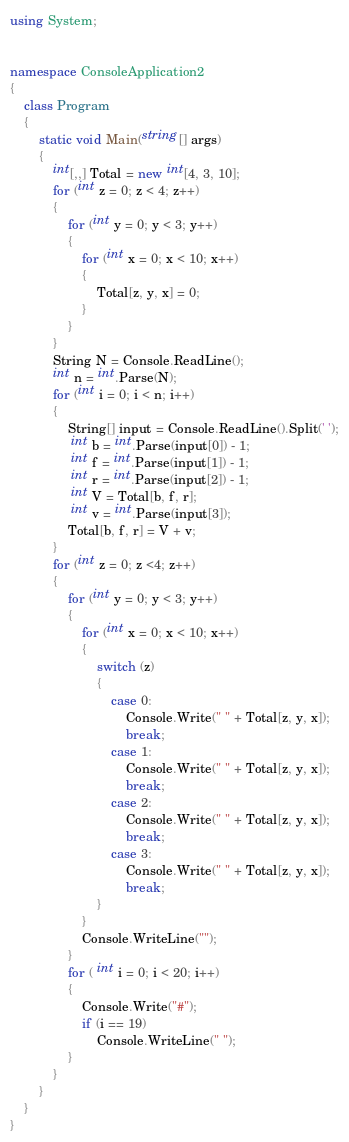<code> <loc_0><loc_0><loc_500><loc_500><_C#_>using System;


namespace ConsoleApplication2
{
    class Program
    {
        static void Main(string[] args)
        {
            int[,,] Total = new int[4, 3, 10];
            for (int z = 0; z < 4; z++)
            {
                for (int y = 0; y < 3; y++)
                {
                    for (int x = 0; x < 10; x++)
                    {
                        Total[z, y, x] = 0;
                    }
                }
            }
            String N = Console.ReadLine();
            int n = int.Parse(N);
            for (int i = 0; i < n; i++)
            {
                String[] input = Console.ReadLine().Split(' ');
                 int b = int.Parse(input[0]) - 1;
                 int f = int.Parse(input[1]) - 1;
                 int r = int.Parse(input[2]) - 1;
                 int V = Total[b, f, r];
                 int v = int.Parse(input[3]);
                Total[b, f, r] = V + v;
            }
            for (int z = 0; z <4; z++)
            {
                for (int y = 0; y < 3; y++)
                {
                    for (int x = 0; x < 10; x++)
                    {
                        switch (z)
                        {
                            case 0:
                                Console.Write(" " + Total[z, y, x]);
                                break;
                            case 1:
                                Console.Write(" " + Total[z, y, x]);
                                break;
                            case 2:
                                Console.Write(" " + Total[z, y, x]);
                                break;
                            case 3:
                                Console.Write(" " + Total[z, y, x]);
                                break;
                        }
                    }
                    Console.WriteLine("");
                }
                for ( int i = 0; i < 20; i++)
                {
                    Console.Write("#");
                    if (i == 19)
                        Console.WriteLine(" ");
                }
            }
        }
    }
}</code> 